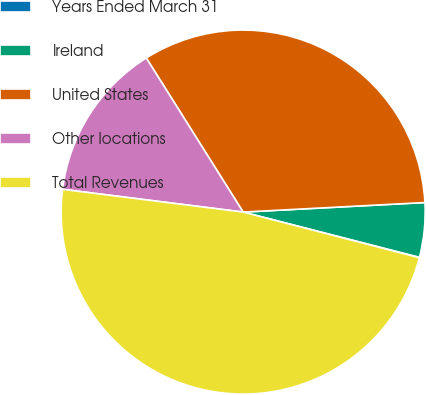Convert chart to OTSL. <chart><loc_0><loc_0><loc_500><loc_500><pie_chart><fcel>Years Ended March 31<fcel>Ireland<fcel>United States<fcel>Other locations<fcel>Total Revenues<nl><fcel>0.04%<fcel>4.83%<fcel>33.1%<fcel>14.07%<fcel>47.96%<nl></chart> 